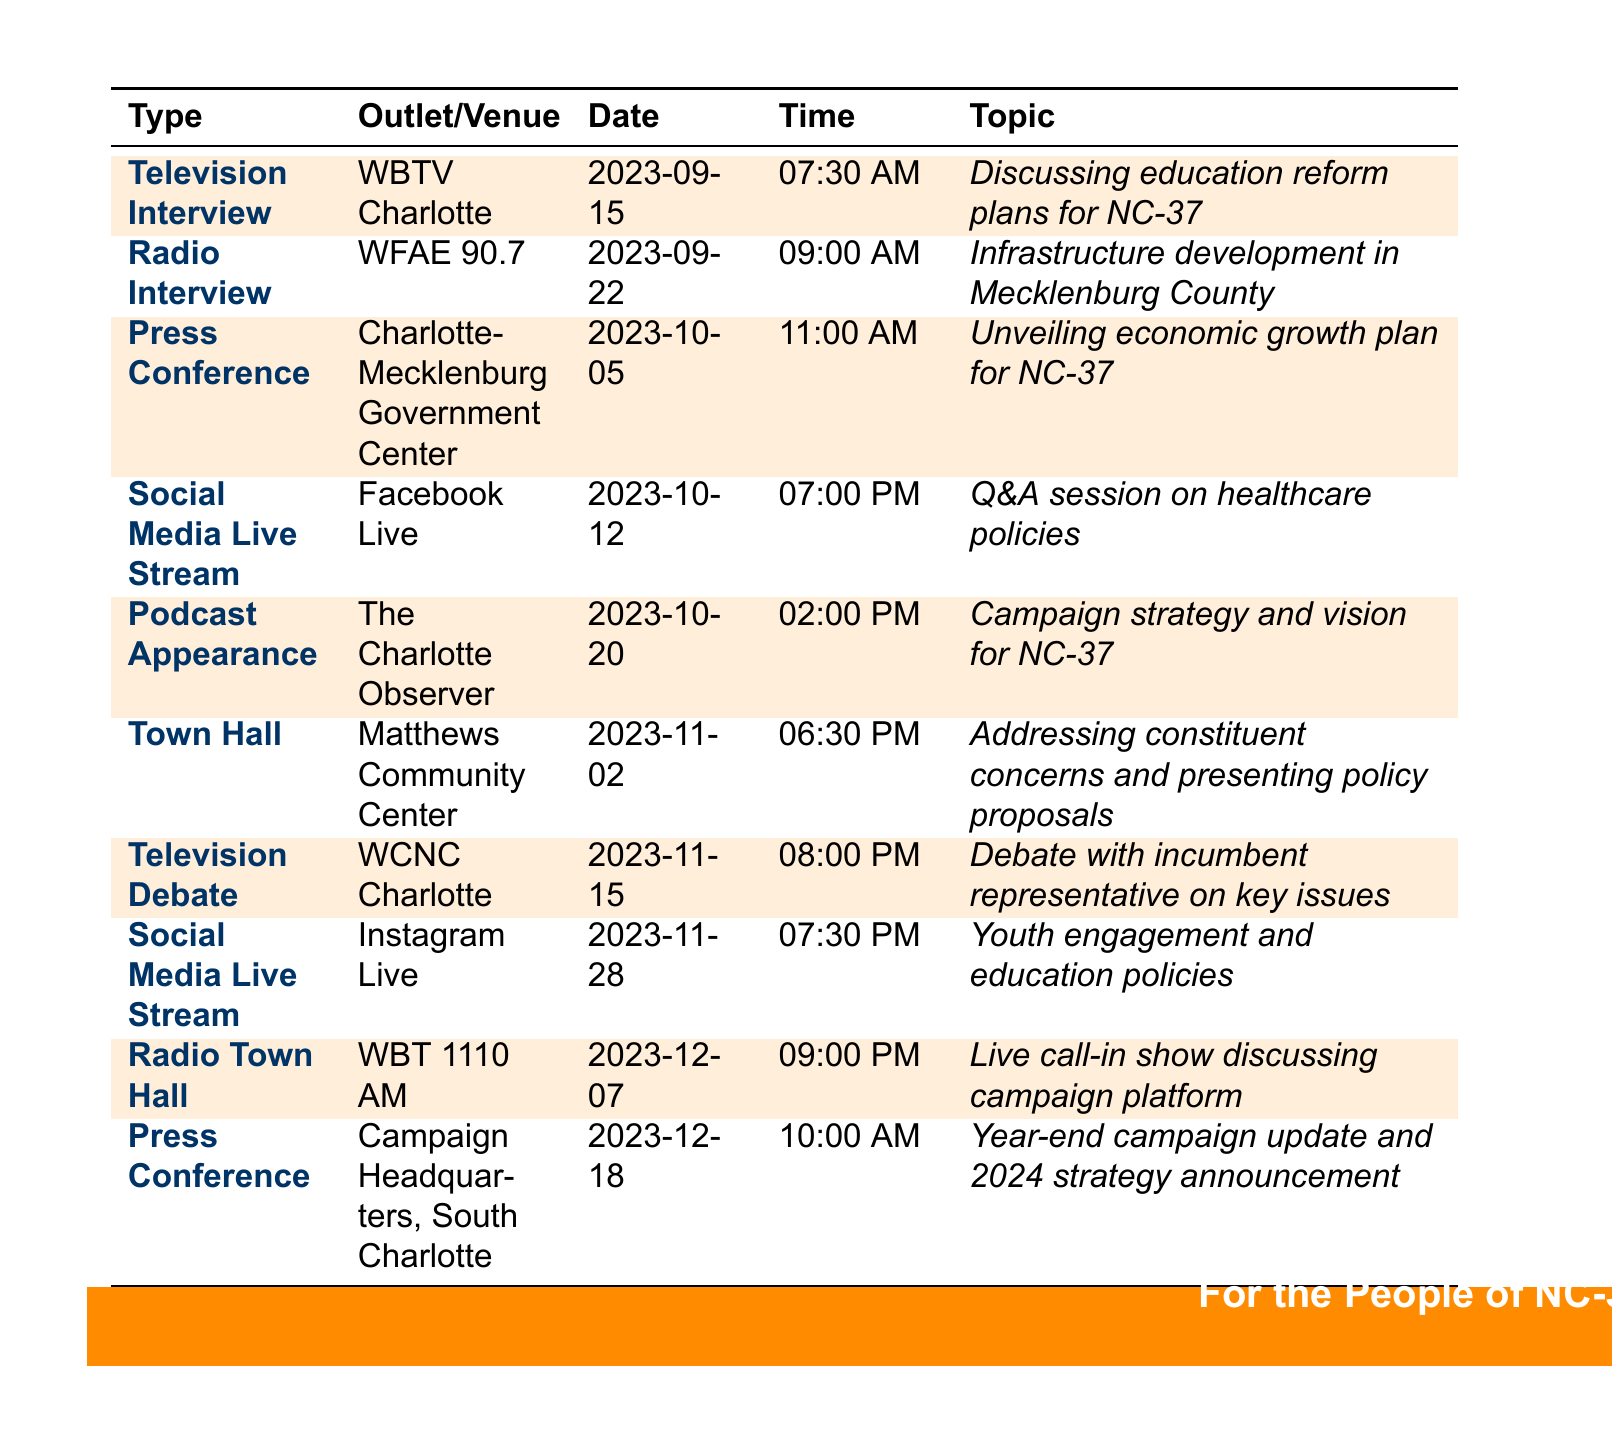What is the date of the first television interview? The first television interview is listed on September 15, 2023.
Answer: September 15, 2023 What time is the press conference on October 5? The press conference is scheduled for 11:00 AM on October 5, 2023.
Answer: 11:00 AM Which social media platform will host a live stream on October 12? The live stream on October 12 will be on Facebook Live.
Answer: Facebook Live How many media appearances are scheduled in December? There are two media appearances scheduled in December: one on December 7 and another on December 18.
Answer: 2 What is the topic of the television debate on November 15? The topic of the television debate is "Debate with incumbent representative on key issues."
Answer: Debate with incumbent representative on key issues What is the venue for the town hall meeting? The town hall meeting is at Matthews Community Center.
Answer: Matthews Community Center Which type of media appearance occurs after the social media live stream on October 12? The next media appearance after the October 12 live stream is a podcast appearance on October 20.
Answer: Podcast Appearance What are the topics discussed in the radio interview on September 22? The radio interview will discuss "Infrastructure development in Mecklenburg County."
Answer: Infrastructure development in Mecklenburg County What is the purpose of the press conference on December 18? The press conference on December 18 is for a "Year-end campaign update and 2024 strategy announcement."
Answer: Year-end campaign update and 2024 strategy announcement 